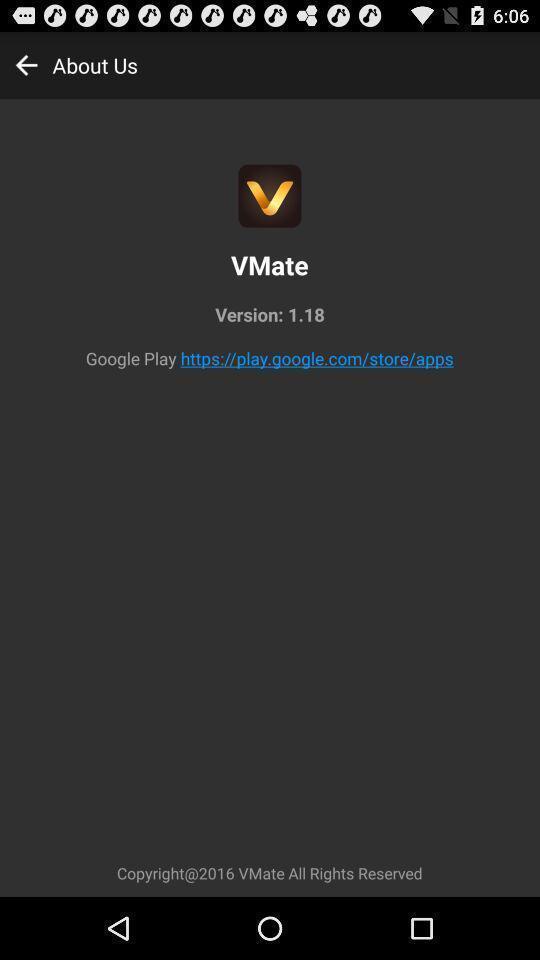Explain what's happening in this screen capture. Page displays the version of a video sharing app. 